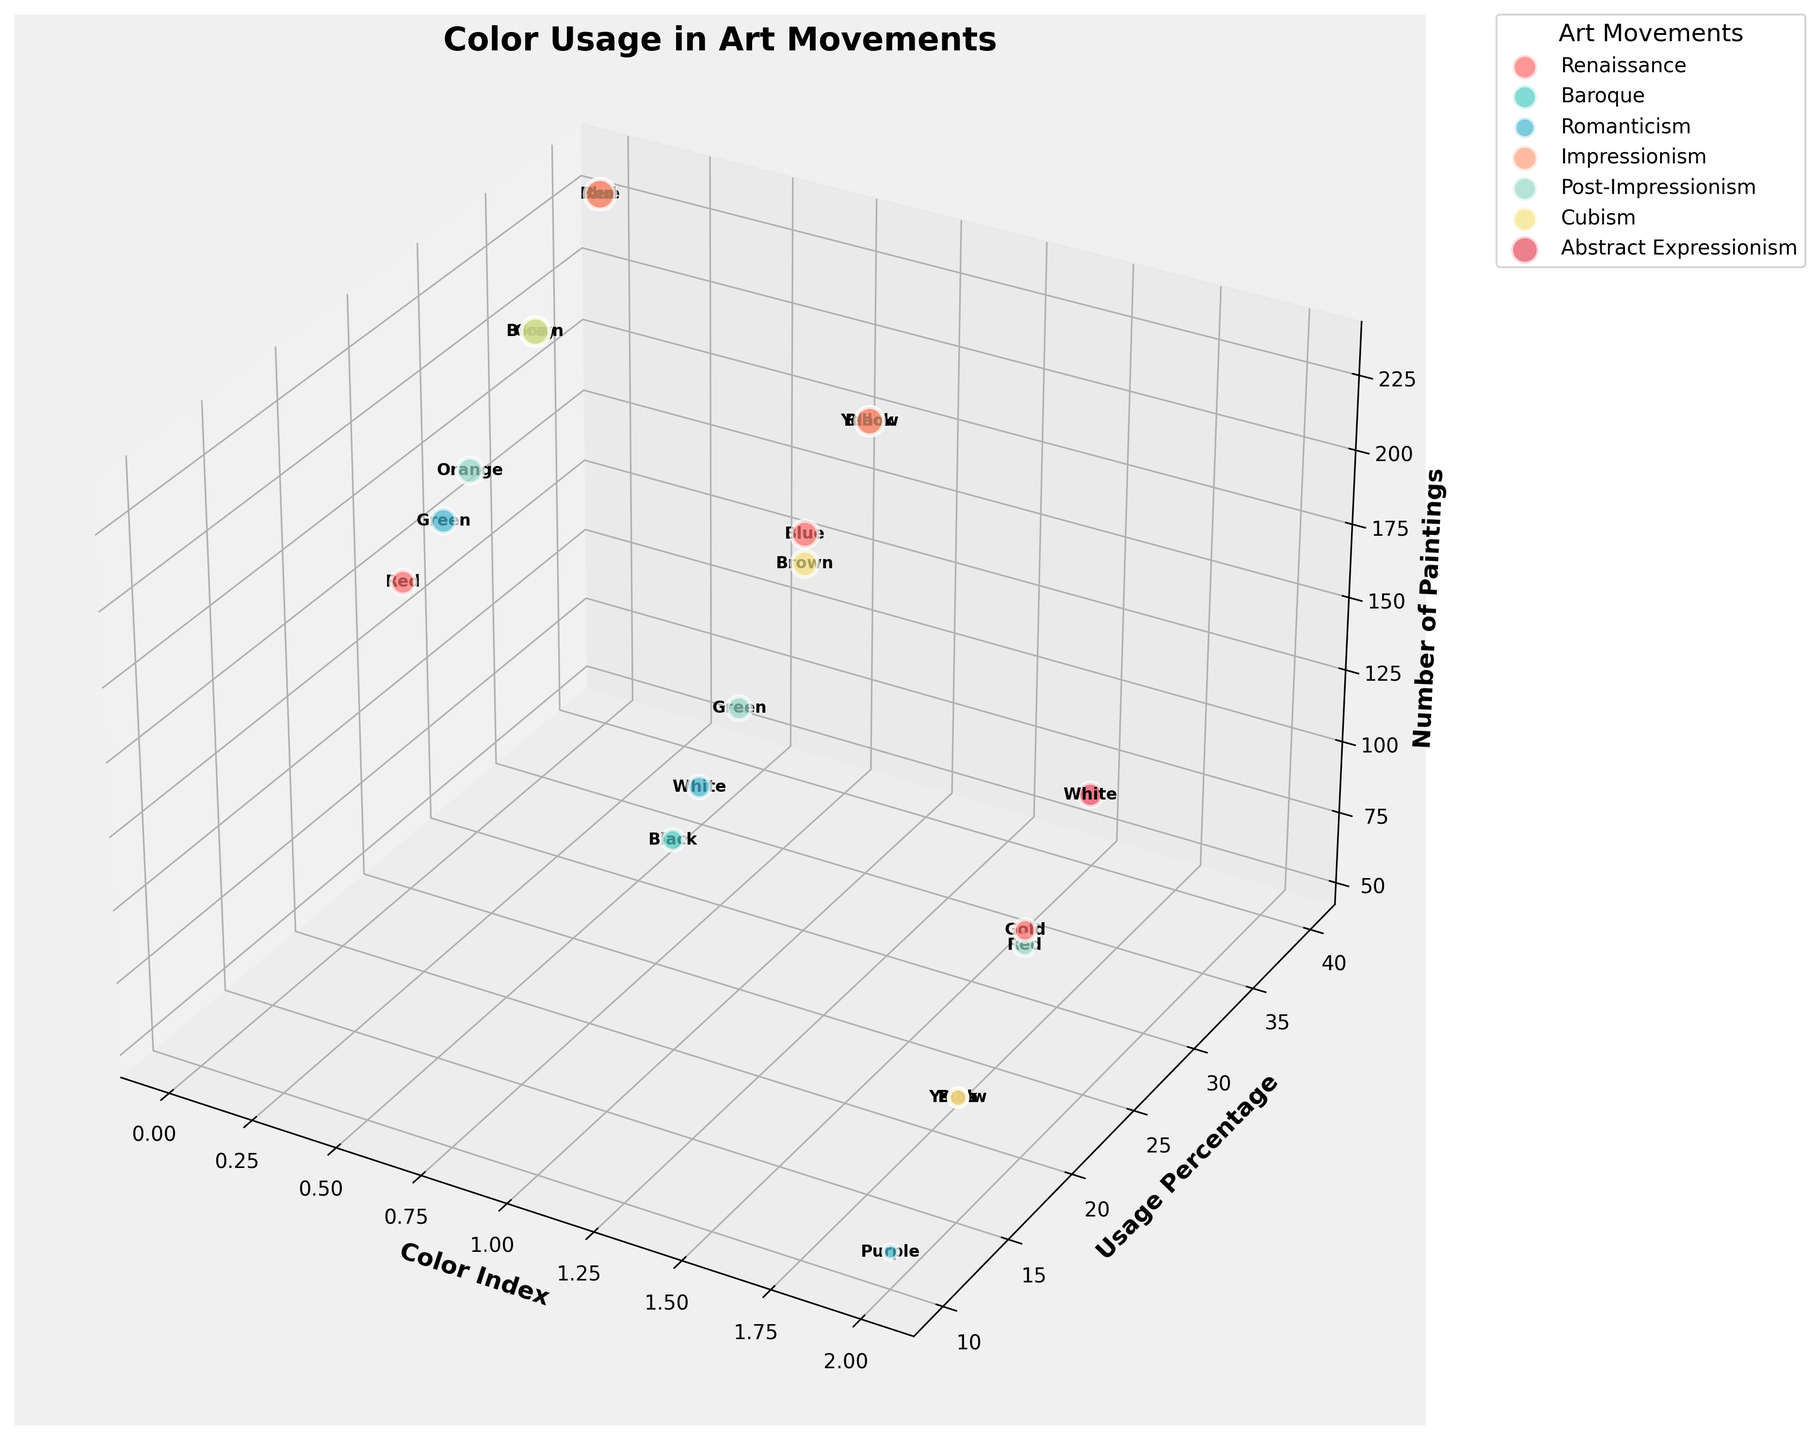What is the title of the figure? The title of the figure is positioned at the top and is easily readable.
Answer: Color Usage in Art Movements How many artistic movements are displayed in the chart? Each artistic movement is labeled within the legend. By counting the labels, we can determine the total number of movements.
Answer: 6 Which color had the highest Usage Percentage in the Impressionism movement? To find this, look for the art movement labeled "Impressionism" and identify the color with the highest y-value (Usage Percentage) among its data points.
Answer: Blue During the Renaissance period, which color had the least Number of Paintings? By identifying the "Renaissance" data points and comparing their z-values (Number of Paintings), we find the color with the smallest value.
Answer: Gold Compare the highest Usage Percentage of Red across all movements. Which movement had the highest value? Locate all data points where the color is Red and observe the y-values (Usage Percentage). Determine the movement associated with the highest percentage.
Answer: Abstract Expressionism What is the approximate number of data points for the Baroque movement? Each bubble on the chart represents a data point, and counting the bubbles labeled with the Baroque movement will give the total number of data points.
Answer: 3 Which color was used most frequently (highest Number of Paintings) in Cubism? Identify the Cubism data points and compare their z-values (Number of Paintings) to determine the color with the highest value.
Answer: Gray What is the average Number of Paintings for colors in Post-Impressionism? Extract the z-values for the Post-Impressionism data points and calculate their arithmetic mean.
Answer: 141.67 Which artistic movement utilized Yellow more frequently, Baroque or Impressionism? Find the Yellow data points for both Baroque and Impressionism and compare their z-values (Number of Paintings). The higher value indicates more frequent use.
Answer: Impressionism How does the Usage Percentage of Green in Romanticism compare to its percentage in Post-Impressionism? Locate the Green data points for both Romanticism and Post-Impressionism and compare their y-values (Usage Percentage).
Answer: Higher in Romanticism Which movement has the lowest overall Usage Percentage? By examining the y-values for all the artistic movements and averaging them per movement, determine the one with the lowest average Usage Percentage.
Answer: Post-Impressionism 